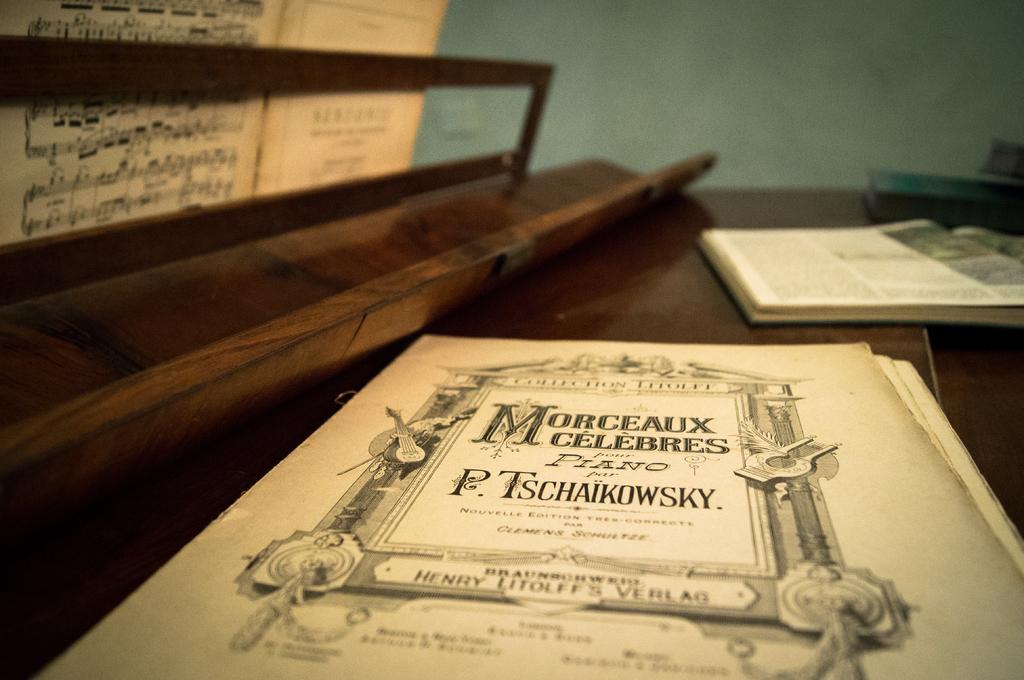Who wrote the manual?
Make the answer very short. P. tschaikowsky. 